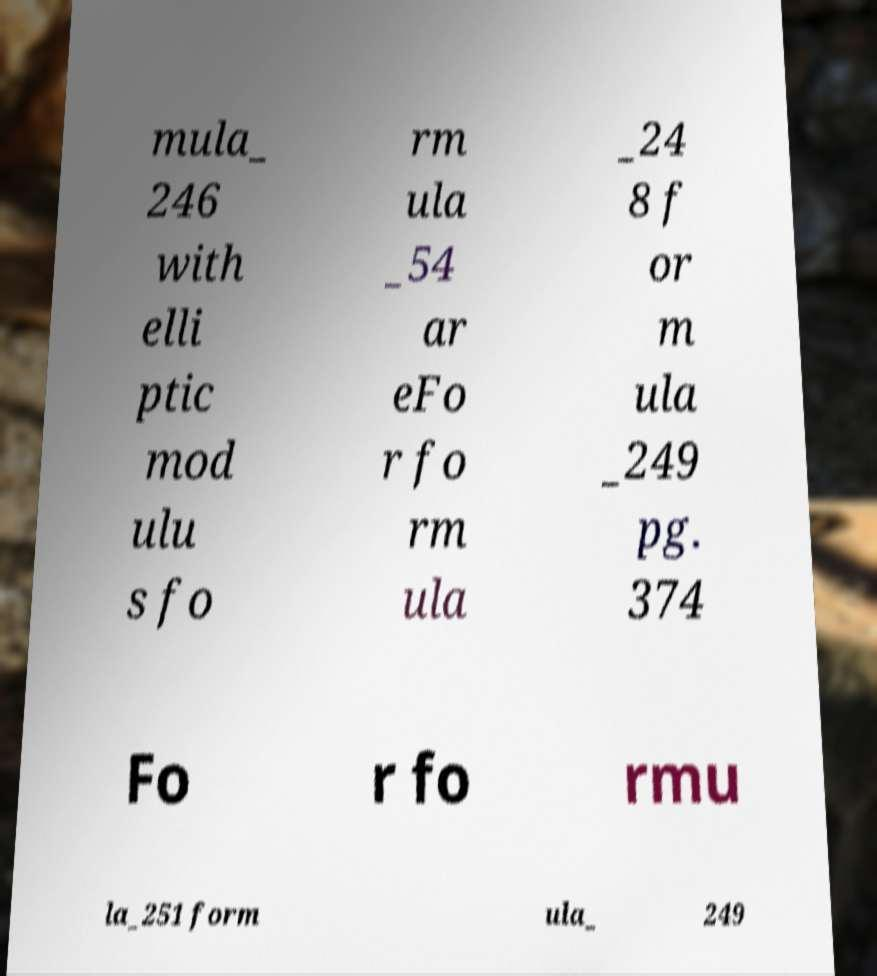There's text embedded in this image that I need extracted. Can you transcribe it verbatim? mula_ 246 with elli ptic mod ulu s fo rm ula _54 ar eFo r fo rm ula _24 8 f or m ula _249 pg. 374 Fo r fo rmu la_251 form ula_ 249 